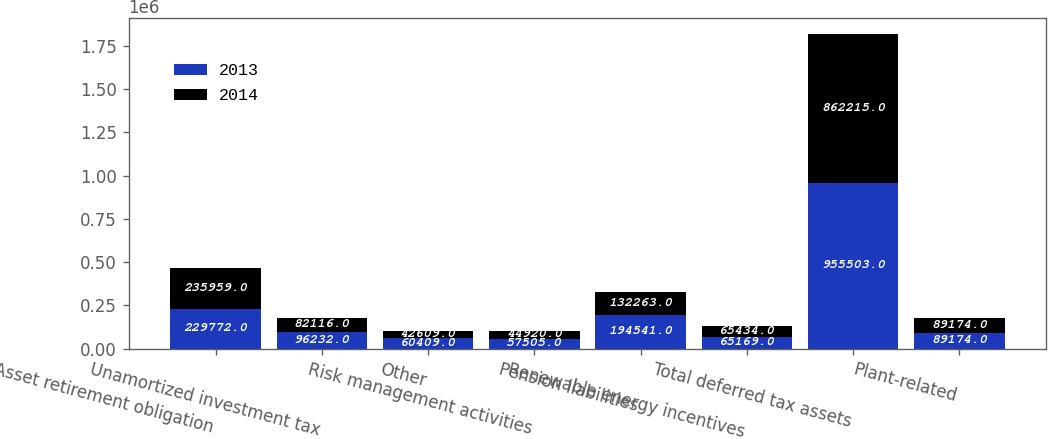<chart> <loc_0><loc_0><loc_500><loc_500><stacked_bar_chart><ecel><fcel>Asset retirement obligation<fcel>Unamortized investment tax<fcel>Other<fcel>Risk management activities<fcel>Pension liabilities<fcel>Renewable energy incentives<fcel>Total deferred tax assets<fcel>Plant-related<nl><fcel>2013<fcel>229772<fcel>96232<fcel>60409<fcel>57505<fcel>194541<fcel>65169<fcel>955503<fcel>89174<nl><fcel>2014<fcel>235959<fcel>82116<fcel>42609<fcel>44920<fcel>132263<fcel>65434<fcel>862215<fcel>89174<nl></chart> 